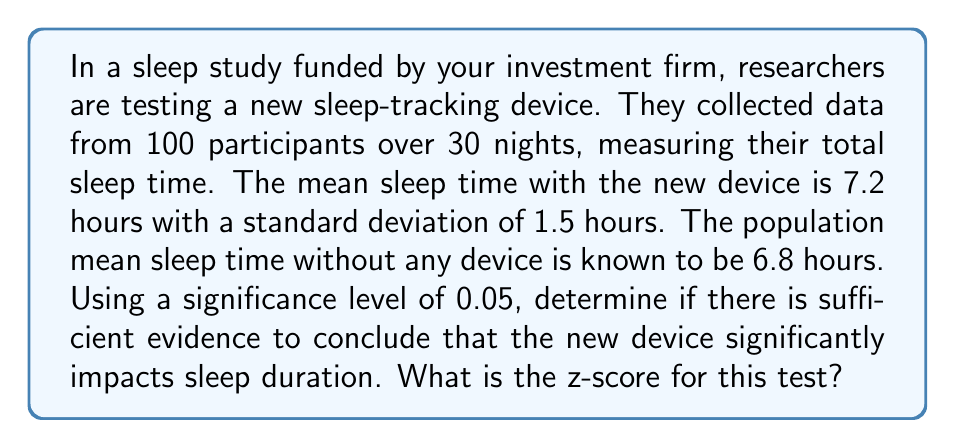Can you solve this math problem? To determine if there's a significant impact on sleep duration, we'll use a z-test since we know the population mean and we have a large sample size (n > 30).

Step 1: State the null and alternative hypotheses
$H_0: \mu = 6.8$ (no significant difference)
$H_a: \mu \neq 6.8$ (significant difference)

Step 2: Calculate the standard error of the mean
$SE = \frac{s}{\sqrt{n}} = \frac{1.5}{\sqrt{100}} = 0.15$

Step 3: Calculate the z-score
$$z = \frac{\bar{x} - \mu_0}{SE} = \frac{7.2 - 6.8}{0.15} = \frac{0.4}{0.15} = 2.67$$

Step 4: Determine the critical value
For a two-tailed test with α = 0.05, the critical z-value is ±1.96.

Step 5: Compare the calculated z-score to the critical value
Since |2.67| > 1.96, we reject the null hypothesis.

This indicates that there is sufficient evidence to conclude that the new sleep-tracking device significantly impacts sleep duration.
Answer: $z = 2.67$ 